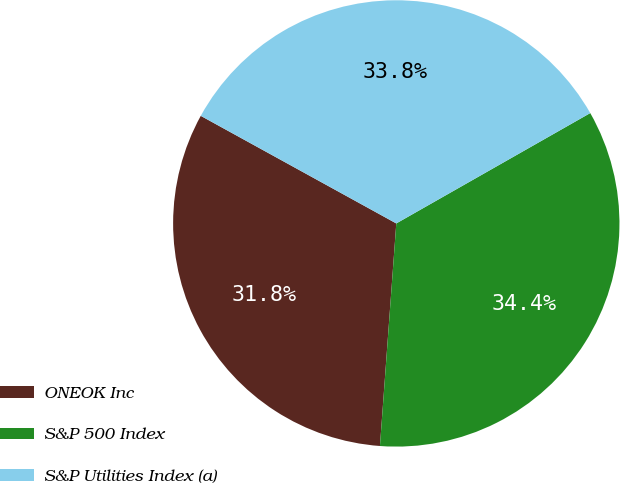<chart> <loc_0><loc_0><loc_500><loc_500><pie_chart><fcel>ONEOK Inc<fcel>S&P 500 Index<fcel>S&P Utilities Index (a)<nl><fcel>31.84%<fcel>34.4%<fcel>33.76%<nl></chart> 